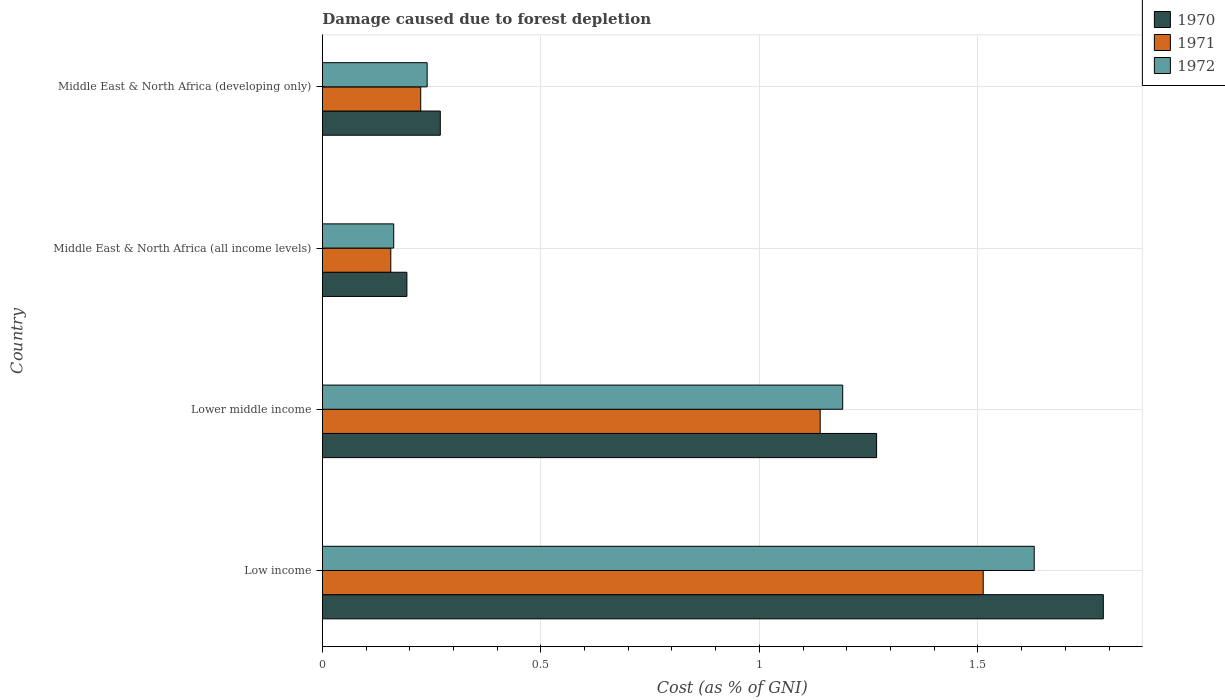How many different coloured bars are there?
Give a very brief answer. 3. Are the number of bars per tick equal to the number of legend labels?
Offer a very short reply. Yes. Are the number of bars on each tick of the Y-axis equal?
Offer a terse response. Yes. How many bars are there on the 3rd tick from the top?
Keep it short and to the point. 3. How many bars are there on the 1st tick from the bottom?
Your answer should be compact. 3. What is the label of the 4th group of bars from the top?
Provide a succinct answer. Low income. In how many cases, is the number of bars for a given country not equal to the number of legend labels?
Your answer should be very brief. 0. What is the cost of damage caused due to forest depletion in 1970 in Lower middle income?
Provide a succinct answer. 1.27. Across all countries, what is the maximum cost of damage caused due to forest depletion in 1970?
Your answer should be compact. 1.79. Across all countries, what is the minimum cost of damage caused due to forest depletion in 1971?
Your answer should be very brief. 0.16. In which country was the cost of damage caused due to forest depletion in 1970 minimum?
Keep it short and to the point. Middle East & North Africa (all income levels). What is the total cost of damage caused due to forest depletion in 1972 in the graph?
Make the answer very short. 3.22. What is the difference between the cost of damage caused due to forest depletion in 1971 in Low income and that in Lower middle income?
Your answer should be compact. 0.37. What is the difference between the cost of damage caused due to forest depletion in 1972 in Lower middle income and the cost of damage caused due to forest depletion in 1970 in Low income?
Keep it short and to the point. -0.6. What is the average cost of damage caused due to forest depletion in 1970 per country?
Your answer should be compact. 0.88. What is the difference between the cost of damage caused due to forest depletion in 1971 and cost of damage caused due to forest depletion in 1970 in Low income?
Offer a very short reply. -0.27. In how many countries, is the cost of damage caused due to forest depletion in 1970 greater than 1.5 %?
Provide a succinct answer. 1. What is the ratio of the cost of damage caused due to forest depletion in 1970 in Low income to that in Lower middle income?
Give a very brief answer. 1.41. Is the cost of damage caused due to forest depletion in 1972 in Lower middle income less than that in Middle East & North Africa (all income levels)?
Make the answer very short. No. What is the difference between the highest and the second highest cost of damage caused due to forest depletion in 1970?
Your answer should be very brief. 0.52. What is the difference between the highest and the lowest cost of damage caused due to forest depletion in 1972?
Offer a very short reply. 1.47. In how many countries, is the cost of damage caused due to forest depletion in 1971 greater than the average cost of damage caused due to forest depletion in 1971 taken over all countries?
Offer a terse response. 2. Is the sum of the cost of damage caused due to forest depletion in 1970 in Low income and Middle East & North Africa (all income levels) greater than the maximum cost of damage caused due to forest depletion in 1972 across all countries?
Keep it short and to the point. Yes. What does the 3rd bar from the top in Low income represents?
Your answer should be very brief. 1970. Is it the case that in every country, the sum of the cost of damage caused due to forest depletion in 1970 and cost of damage caused due to forest depletion in 1971 is greater than the cost of damage caused due to forest depletion in 1972?
Keep it short and to the point. Yes. How many bars are there?
Your answer should be compact. 12. Are all the bars in the graph horizontal?
Provide a short and direct response. Yes. Are the values on the major ticks of X-axis written in scientific E-notation?
Make the answer very short. No. Does the graph contain any zero values?
Provide a short and direct response. No. How many legend labels are there?
Give a very brief answer. 3. How are the legend labels stacked?
Give a very brief answer. Vertical. What is the title of the graph?
Ensure brevity in your answer.  Damage caused due to forest depletion. Does "2003" appear as one of the legend labels in the graph?
Give a very brief answer. No. What is the label or title of the X-axis?
Make the answer very short. Cost (as % of GNI). What is the label or title of the Y-axis?
Ensure brevity in your answer.  Country. What is the Cost (as % of GNI) of 1970 in Low income?
Give a very brief answer. 1.79. What is the Cost (as % of GNI) in 1971 in Low income?
Your answer should be compact. 1.51. What is the Cost (as % of GNI) of 1972 in Low income?
Offer a terse response. 1.63. What is the Cost (as % of GNI) in 1970 in Lower middle income?
Provide a succinct answer. 1.27. What is the Cost (as % of GNI) of 1971 in Lower middle income?
Offer a terse response. 1.14. What is the Cost (as % of GNI) in 1972 in Lower middle income?
Provide a short and direct response. 1.19. What is the Cost (as % of GNI) of 1970 in Middle East & North Africa (all income levels)?
Keep it short and to the point. 0.19. What is the Cost (as % of GNI) in 1971 in Middle East & North Africa (all income levels)?
Make the answer very short. 0.16. What is the Cost (as % of GNI) in 1972 in Middle East & North Africa (all income levels)?
Your response must be concise. 0.16. What is the Cost (as % of GNI) of 1970 in Middle East & North Africa (developing only)?
Your response must be concise. 0.27. What is the Cost (as % of GNI) of 1971 in Middle East & North Africa (developing only)?
Provide a succinct answer. 0.23. What is the Cost (as % of GNI) in 1972 in Middle East & North Africa (developing only)?
Offer a terse response. 0.24. Across all countries, what is the maximum Cost (as % of GNI) of 1970?
Give a very brief answer. 1.79. Across all countries, what is the maximum Cost (as % of GNI) of 1971?
Your answer should be very brief. 1.51. Across all countries, what is the maximum Cost (as % of GNI) of 1972?
Ensure brevity in your answer.  1.63. Across all countries, what is the minimum Cost (as % of GNI) of 1970?
Provide a succinct answer. 0.19. Across all countries, what is the minimum Cost (as % of GNI) of 1971?
Your answer should be compact. 0.16. Across all countries, what is the minimum Cost (as % of GNI) of 1972?
Offer a terse response. 0.16. What is the total Cost (as % of GNI) of 1970 in the graph?
Your answer should be very brief. 3.52. What is the total Cost (as % of GNI) in 1971 in the graph?
Make the answer very short. 3.03. What is the total Cost (as % of GNI) in 1972 in the graph?
Provide a succinct answer. 3.22. What is the difference between the Cost (as % of GNI) of 1970 in Low income and that in Lower middle income?
Offer a terse response. 0.52. What is the difference between the Cost (as % of GNI) in 1971 in Low income and that in Lower middle income?
Give a very brief answer. 0.37. What is the difference between the Cost (as % of GNI) in 1972 in Low income and that in Lower middle income?
Give a very brief answer. 0.44. What is the difference between the Cost (as % of GNI) in 1970 in Low income and that in Middle East & North Africa (all income levels)?
Provide a short and direct response. 1.59. What is the difference between the Cost (as % of GNI) in 1971 in Low income and that in Middle East & North Africa (all income levels)?
Keep it short and to the point. 1.36. What is the difference between the Cost (as % of GNI) of 1972 in Low income and that in Middle East & North Africa (all income levels)?
Offer a very short reply. 1.47. What is the difference between the Cost (as % of GNI) in 1970 in Low income and that in Middle East & North Africa (developing only)?
Your answer should be very brief. 1.52. What is the difference between the Cost (as % of GNI) of 1971 in Low income and that in Middle East & North Africa (developing only)?
Keep it short and to the point. 1.29. What is the difference between the Cost (as % of GNI) of 1972 in Low income and that in Middle East & North Africa (developing only)?
Provide a succinct answer. 1.39. What is the difference between the Cost (as % of GNI) of 1970 in Lower middle income and that in Middle East & North Africa (all income levels)?
Make the answer very short. 1.07. What is the difference between the Cost (as % of GNI) in 1971 in Lower middle income and that in Middle East & North Africa (all income levels)?
Provide a succinct answer. 0.98. What is the difference between the Cost (as % of GNI) in 1972 in Lower middle income and that in Middle East & North Africa (all income levels)?
Ensure brevity in your answer.  1.03. What is the difference between the Cost (as % of GNI) of 1970 in Lower middle income and that in Middle East & North Africa (developing only)?
Keep it short and to the point. 1. What is the difference between the Cost (as % of GNI) in 1971 in Lower middle income and that in Middle East & North Africa (developing only)?
Ensure brevity in your answer.  0.91. What is the difference between the Cost (as % of GNI) in 1972 in Lower middle income and that in Middle East & North Africa (developing only)?
Offer a terse response. 0.95. What is the difference between the Cost (as % of GNI) in 1970 in Middle East & North Africa (all income levels) and that in Middle East & North Africa (developing only)?
Provide a short and direct response. -0.08. What is the difference between the Cost (as % of GNI) in 1971 in Middle East & North Africa (all income levels) and that in Middle East & North Africa (developing only)?
Give a very brief answer. -0.07. What is the difference between the Cost (as % of GNI) in 1972 in Middle East & North Africa (all income levels) and that in Middle East & North Africa (developing only)?
Your answer should be very brief. -0.08. What is the difference between the Cost (as % of GNI) of 1970 in Low income and the Cost (as % of GNI) of 1971 in Lower middle income?
Offer a terse response. 0.65. What is the difference between the Cost (as % of GNI) of 1970 in Low income and the Cost (as % of GNI) of 1972 in Lower middle income?
Offer a very short reply. 0.6. What is the difference between the Cost (as % of GNI) of 1971 in Low income and the Cost (as % of GNI) of 1972 in Lower middle income?
Offer a terse response. 0.32. What is the difference between the Cost (as % of GNI) of 1970 in Low income and the Cost (as % of GNI) of 1971 in Middle East & North Africa (all income levels)?
Provide a succinct answer. 1.63. What is the difference between the Cost (as % of GNI) of 1970 in Low income and the Cost (as % of GNI) of 1972 in Middle East & North Africa (all income levels)?
Give a very brief answer. 1.62. What is the difference between the Cost (as % of GNI) in 1971 in Low income and the Cost (as % of GNI) in 1972 in Middle East & North Africa (all income levels)?
Offer a terse response. 1.35. What is the difference between the Cost (as % of GNI) in 1970 in Low income and the Cost (as % of GNI) in 1971 in Middle East & North Africa (developing only)?
Provide a short and direct response. 1.56. What is the difference between the Cost (as % of GNI) in 1970 in Low income and the Cost (as % of GNI) in 1972 in Middle East & North Africa (developing only)?
Ensure brevity in your answer.  1.55. What is the difference between the Cost (as % of GNI) in 1971 in Low income and the Cost (as % of GNI) in 1972 in Middle East & North Africa (developing only)?
Keep it short and to the point. 1.27. What is the difference between the Cost (as % of GNI) of 1970 in Lower middle income and the Cost (as % of GNI) of 1971 in Middle East & North Africa (all income levels)?
Provide a succinct answer. 1.11. What is the difference between the Cost (as % of GNI) of 1970 in Lower middle income and the Cost (as % of GNI) of 1972 in Middle East & North Africa (all income levels)?
Your response must be concise. 1.1. What is the difference between the Cost (as % of GNI) of 1971 in Lower middle income and the Cost (as % of GNI) of 1972 in Middle East & North Africa (all income levels)?
Your answer should be very brief. 0.98. What is the difference between the Cost (as % of GNI) in 1970 in Lower middle income and the Cost (as % of GNI) in 1971 in Middle East & North Africa (developing only)?
Ensure brevity in your answer.  1.04. What is the difference between the Cost (as % of GNI) in 1970 in Lower middle income and the Cost (as % of GNI) in 1972 in Middle East & North Africa (developing only)?
Offer a terse response. 1.03. What is the difference between the Cost (as % of GNI) of 1971 in Lower middle income and the Cost (as % of GNI) of 1972 in Middle East & North Africa (developing only)?
Keep it short and to the point. 0.9. What is the difference between the Cost (as % of GNI) in 1970 in Middle East & North Africa (all income levels) and the Cost (as % of GNI) in 1971 in Middle East & North Africa (developing only)?
Make the answer very short. -0.03. What is the difference between the Cost (as % of GNI) in 1970 in Middle East & North Africa (all income levels) and the Cost (as % of GNI) in 1972 in Middle East & North Africa (developing only)?
Your response must be concise. -0.05. What is the difference between the Cost (as % of GNI) in 1971 in Middle East & North Africa (all income levels) and the Cost (as % of GNI) in 1972 in Middle East & North Africa (developing only)?
Make the answer very short. -0.08. What is the average Cost (as % of GNI) of 1970 per country?
Make the answer very short. 0.88. What is the average Cost (as % of GNI) of 1971 per country?
Your answer should be compact. 0.76. What is the average Cost (as % of GNI) in 1972 per country?
Make the answer very short. 0.81. What is the difference between the Cost (as % of GNI) in 1970 and Cost (as % of GNI) in 1971 in Low income?
Provide a short and direct response. 0.27. What is the difference between the Cost (as % of GNI) of 1970 and Cost (as % of GNI) of 1972 in Low income?
Your response must be concise. 0.16. What is the difference between the Cost (as % of GNI) of 1971 and Cost (as % of GNI) of 1972 in Low income?
Provide a short and direct response. -0.12. What is the difference between the Cost (as % of GNI) of 1970 and Cost (as % of GNI) of 1971 in Lower middle income?
Your answer should be very brief. 0.13. What is the difference between the Cost (as % of GNI) of 1970 and Cost (as % of GNI) of 1972 in Lower middle income?
Your answer should be compact. 0.08. What is the difference between the Cost (as % of GNI) of 1971 and Cost (as % of GNI) of 1972 in Lower middle income?
Provide a succinct answer. -0.05. What is the difference between the Cost (as % of GNI) in 1970 and Cost (as % of GNI) in 1971 in Middle East & North Africa (all income levels)?
Give a very brief answer. 0.04. What is the difference between the Cost (as % of GNI) in 1970 and Cost (as % of GNI) in 1972 in Middle East & North Africa (all income levels)?
Provide a succinct answer. 0.03. What is the difference between the Cost (as % of GNI) of 1971 and Cost (as % of GNI) of 1972 in Middle East & North Africa (all income levels)?
Give a very brief answer. -0.01. What is the difference between the Cost (as % of GNI) in 1970 and Cost (as % of GNI) in 1971 in Middle East & North Africa (developing only)?
Your answer should be very brief. 0.04. What is the difference between the Cost (as % of GNI) of 1970 and Cost (as % of GNI) of 1972 in Middle East & North Africa (developing only)?
Provide a succinct answer. 0.03. What is the difference between the Cost (as % of GNI) of 1971 and Cost (as % of GNI) of 1972 in Middle East & North Africa (developing only)?
Offer a very short reply. -0.01. What is the ratio of the Cost (as % of GNI) in 1970 in Low income to that in Lower middle income?
Give a very brief answer. 1.41. What is the ratio of the Cost (as % of GNI) of 1971 in Low income to that in Lower middle income?
Provide a succinct answer. 1.33. What is the ratio of the Cost (as % of GNI) in 1972 in Low income to that in Lower middle income?
Give a very brief answer. 1.37. What is the ratio of the Cost (as % of GNI) in 1970 in Low income to that in Middle East & North Africa (all income levels)?
Offer a terse response. 9.24. What is the ratio of the Cost (as % of GNI) of 1971 in Low income to that in Middle East & North Africa (all income levels)?
Your response must be concise. 9.65. What is the ratio of the Cost (as % of GNI) of 1972 in Low income to that in Middle East & North Africa (all income levels)?
Keep it short and to the point. 9.97. What is the ratio of the Cost (as % of GNI) in 1970 in Low income to that in Middle East & North Africa (developing only)?
Keep it short and to the point. 6.62. What is the ratio of the Cost (as % of GNI) in 1971 in Low income to that in Middle East & North Africa (developing only)?
Your response must be concise. 6.72. What is the ratio of the Cost (as % of GNI) in 1972 in Low income to that in Middle East & North Africa (developing only)?
Give a very brief answer. 6.79. What is the ratio of the Cost (as % of GNI) of 1970 in Lower middle income to that in Middle East & North Africa (all income levels)?
Ensure brevity in your answer.  6.55. What is the ratio of the Cost (as % of GNI) of 1971 in Lower middle income to that in Middle East & North Africa (all income levels)?
Provide a succinct answer. 7.27. What is the ratio of the Cost (as % of GNI) of 1972 in Lower middle income to that in Middle East & North Africa (all income levels)?
Your response must be concise. 7.29. What is the ratio of the Cost (as % of GNI) of 1970 in Lower middle income to that in Middle East & North Africa (developing only)?
Make the answer very short. 4.7. What is the ratio of the Cost (as % of GNI) in 1971 in Lower middle income to that in Middle East & North Africa (developing only)?
Provide a short and direct response. 5.06. What is the ratio of the Cost (as % of GNI) of 1972 in Lower middle income to that in Middle East & North Africa (developing only)?
Give a very brief answer. 4.96. What is the ratio of the Cost (as % of GNI) in 1970 in Middle East & North Africa (all income levels) to that in Middle East & North Africa (developing only)?
Your response must be concise. 0.72. What is the ratio of the Cost (as % of GNI) of 1971 in Middle East & North Africa (all income levels) to that in Middle East & North Africa (developing only)?
Your answer should be compact. 0.7. What is the ratio of the Cost (as % of GNI) in 1972 in Middle East & North Africa (all income levels) to that in Middle East & North Africa (developing only)?
Make the answer very short. 0.68. What is the difference between the highest and the second highest Cost (as % of GNI) of 1970?
Your response must be concise. 0.52. What is the difference between the highest and the second highest Cost (as % of GNI) of 1971?
Provide a short and direct response. 0.37. What is the difference between the highest and the second highest Cost (as % of GNI) of 1972?
Keep it short and to the point. 0.44. What is the difference between the highest and the lowest Cost (as % of GNI) in 1970?
Offer a very short reply. 1.59. What is the difference between the highest and the lowest Cost (as % of GNI) in 1971?
Provide a succinct answer. 1.36. What is the difference between the highest and the lowest Cost (as % of GNI) of 1972?
Provide a succinct answer. 1.47. 